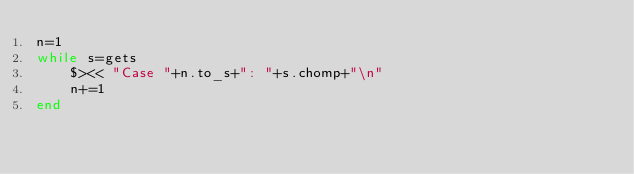<code> <loc_0><loc_0><loc_500><loc_500><_Ruby_>n=1
while s=gets
    $><< "Case "+n.to_s+": "+s.chomp+"\n"
    n+=1
end</code> 